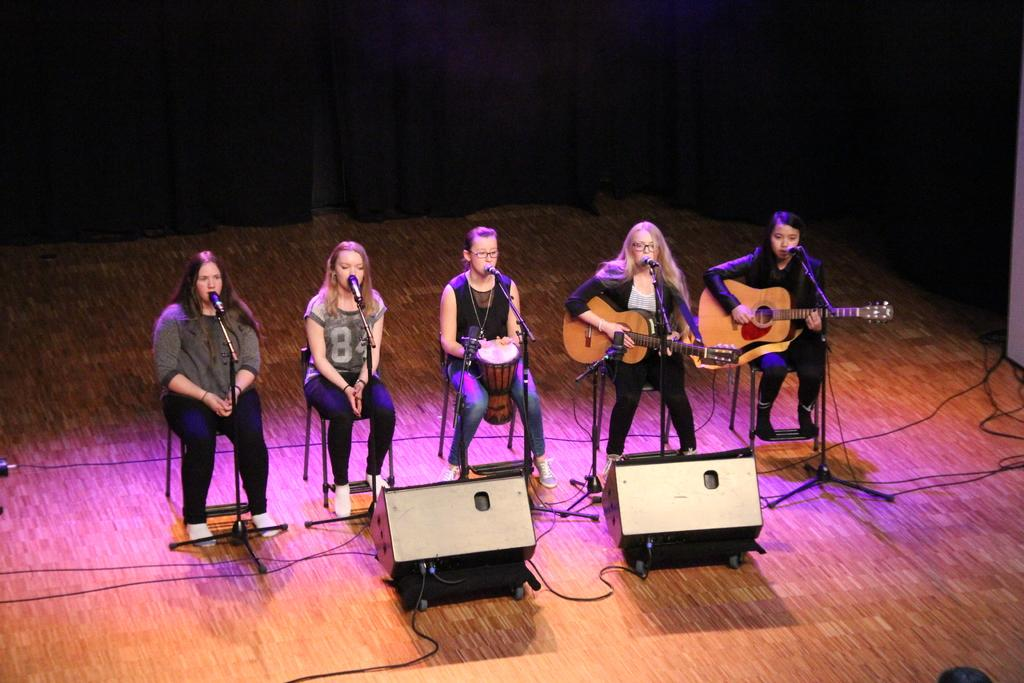What are the women doing in the image? The women are sitting on chairs in front of a microphone. Are there any musical instruments being played in the image? Yes, there are two women playing guitar on a stage. Where is the stage located in the image? The stage is on the right side of the image. What type of spoon is being used to stir the stew on the stage? There is no spoon or stew present in the image; it features women sitting in front of a microphone and playing guitar on a stage. 